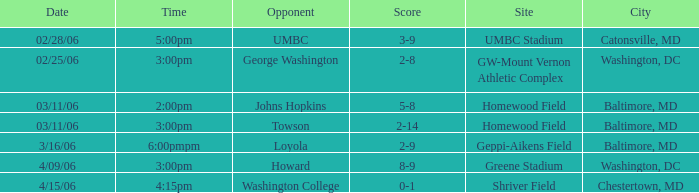Which team faced off at homewood field, ending with a 5-8 score? Johns Hopkins. 